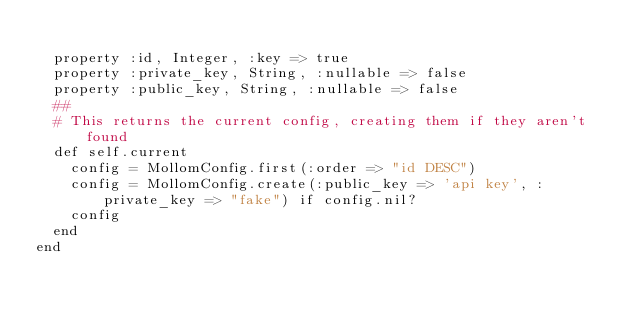Convert code to text. <code><loc_0><loc_0><loc_500><loc_500><_Ruby_>  
  property :id, Integer, :key => true
  property :private_key, String, :nullable => false
  property :public_key, String, :nullable => false
  ##
  # This returns the current config, creating them if they aren't found
  def self.current
    config = MollomConfig.first(:order => "id DESC")
    config = MollomConfig.create(:public_key => 'api key', :private_key => "fake") if config.nil?
    config
  end
end
</code> 